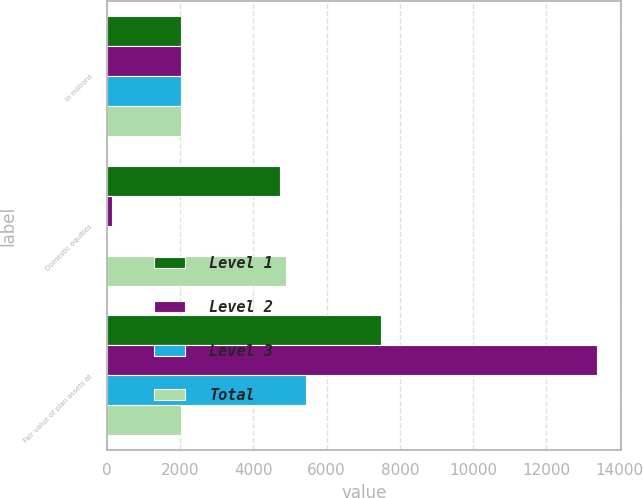Convert chart to OTSL. <chart><loc_0><loc_0><loc_500><loc_500><stacked_bar_chart><ecel><fcel>in millions<fcel>Domestic equities<fcel>Fair value of plan assets at<nl><fcel>Level 1<fcel>2014<fcel>4729<fcel>7474<nl><fcel>Level 2<fcel>2014<fcel>147<fcel>13378<nl><fcel>Level 3<fcel>2014<fcel>2<fcel>5427<nl><fcel>Total<fcel>2014<fcel>4878<fcel>2014<nl></chart> 